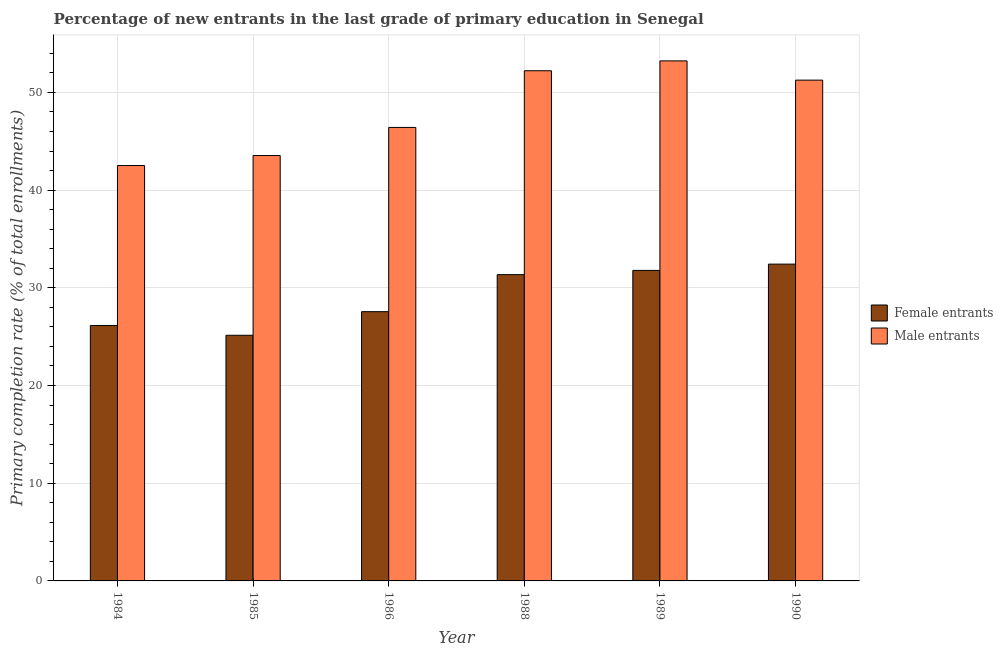How many groups of bars are there?
Offer a very short reply. 6. How many bars are there on the 1st tick from the right?
Your answer should be compact. 2. What is the label of the 1st group of bars from the left?
Provide a succinct answer. 1984. In how many cases, is the number of bars for a given year not equal to the number of legend labels?
Your answer should be very brief. 0. What is the primary completion rate of female entrants in 1985?
Your answer should be very brief. 25.14. Across all years, what is the maximum primary completion rate of male entrants?
Offer a very short reply. 53.23. Across all years, what is the minimum primary completion rate of male entrants?
Your answer should be very brief. 42.52. What is the total primary completion rate of male entrants in the graph?
Your answer should be very brief. 289.19. What is the difference between the primary completion rate of male entrants in 1985 and that in 1986?
Ensure brevity in your answer.  -2.88. What is the difference between the primary completion rate of male entrants in 1990 and the primary completion rate of female entrants in 1984?
Ensure brevity in your answer.  8.74. What is the average primary completion rate of female entrants per year?
Provide a short and direct response. 29.07. What is the ratio of the primary completion rate of female entrants in 1984 to that in 1988?
Your answer should be very brief. 0.83. What is the difference between the highest and the second highest primary completion rate of female entrants?
Provide a short and direct response. 0.64. What is the difference between the highest and the lowest primary completion rate of female entrants?
Your answer should be compact. 7.28. What does the 1st bar from the left in 1984 represents?
Keep it short and to the point. Female entrants. What does the 1st bar from the right in 1985 represents?
Keep it short and to the point. Male entrants. What is the difference between two consecutive major ticks on the Y-axis?
Provide a succinct answer. 10. Does the graph contain any zero values?
Your response must be concise. No. Does the graph contain grids?
Make the answer very short. Yes. How many legend labels are there?
Your response must be concise. 2. What is the title of the graph?
Make the answer very short. Percentage of new entrants in the last grade of primary education in Senegal. Does "RDB concessional" appear as one of the legend labels in the graph?
Offer a terse response. No. What is the label or title of the X-axis?
Your answer should be very brief. Year. What is the label or title of the Y-axis?
Your answer should be very brief. Primary completion rate (% of total enrollments). What is the Primary completion rate (% of total enrollments) of Female entrants in 1984?
Offer a very short reply. 26.14. What is the Primary completion rate (% of total enrollments) of Male entrants in 1984?
Ensure brevity in your answer.  42.52. What is the Primary completion rate (% of total enrollments) in Female entrants in 1985?
Provide a succinct answer. 25.14. What is the Primary completion rate (% of total enrollments) of Male entrants in 1985?
Offer a very short reply. 43.54. What is the Primary completion rate (% of total enrollments) in Female entrants in 1986?
Provide a short and direct response. 27.56. What is the Primary completion rate (% of total enrollments) of Male entrants in 1986?
Offer a very short reply. 46.42. What is the Primary completion rate (% of total enrollments) in Female entrants in 1988?
Provide a succinct answer. 31.35. What is the Primary completion rate (% of total enrollments) of Male entrants in 1988?
Your answer should be very brief. 52.22. What is the Primary completion rate (% of total enrollments) of Female entrants in 1989?
Your answer should be very brief. 31.78. What is the Primary completion rate (% of total enrollments) in Male entrants in 1989?
Offer a very short reply. 53.23. What is the Primary completion rate (% of total enrollments) in Female entrants in 1990?
Ensure brevity in your answer.  32.43. What is the Primary completion rate (% of total enrollments) of Male entrants in 1990?
Your answer should be compact. 51.26. Across all years, what is the maximum Primary completion rate (% of total enrollments) of Female entrants?
Ensure brevity in your answer.  32.43. Across all years, what is the maximum Primary completion rate (% of total enrollments) in Male entrants?
Give a very brief answer. 53.23. Across all years, what is the minimum Primary completion rate (% of total enrollments) of Female entrants?
Provide a succinct answer. 25.14. Across all years, what is the minimum Primary completion rate (% of total enrollments) of Male entrants?
Ensure brevity in your answer.  42.52. What is the total Primary completion rate (% of total enrollments) of Female entrants in the graph?
Your answer should be very brief. 174.41. What is the total Primary completion rate (% of total enrollments) in Male entrants in the graph?
Ensure brevity in your answer.  289.19. What is the difference between the Primary completion rate (% of total enrollments) of Male entrants in 1984 and that in 1985?
Offer a very short reply. -1.02. What is the difference between the Primary completion rate (% of total enrollments) in Female entrants in 1984 and that in 1986?
Provide a short and direct response. -1.42. What is the difference between the Primary completion rate (% of total enrollments) of Male entrants in 1984 and that in 1986?
Make the answer very short. -3.9. What is the difference between the Primary completion rate (% of total enrollments) in Female entrants in 1984 and that in 1988?
Make the answer very short. -5.21. What is the difference between the Primary completion rate (% of total enrollments) in Male entrants in 1984 and that in 1988?
Offer a terse response. -9.7. What is the difference between the Primary completion rate (% of total enrollments) of Female entrants in 1984 and that in 1989?
Make the answer very short. -5.64. What is the difference between the Primary completion rate (% of total enrollments) in Male entrants in 1984 and that in 1989?
Provide a short and direct response. -10.71. What is the difference between the Primary completion rate (% of total enrollments) of Female entrants in 1984 and that in 1990?
Ensure brevity in your answer.  -6.28. What is the difference between the Primary completion rate (% of total enrollments) in Male entrants in 1984 and that in 1990?
Offer a terse response. -8.74. What is the difference between the Primary completion rate (% of total enrollments) in Female entrants in 1985 and that in 1986?
Give a very brief answer. -2.42. What is the difference between the Primary completion rate (% of total enrollments) of Male entrants in 1985 and that in 1986?
Your response must be concise. -2.88. What is the difference between the Primary completion rate (% of total enrollments) in Female entrants in 1985 and that in 1988?
Keep it short and to the point. -6.21. What is the difference between the Primary completion rate (% of total enrollments) of Male entrants in 1985 and that in 1988?
Provide a short and direct response. -8.68. What is the difference between the Primary completion rate (% of total enrollments) of Female entrants in 1985 and that in 1989?
Keep it short and to the point. -6.64. What is the difference between the Primary completion rate (% of total enrollments) in Male entrants in 1985 and that in 1989?
Offer a terse response. -9.69. What is the difference between the Primary completion rate (% of total enrollments) in Female entrants in 1985 and that in 1990?
Your response must be concise. -7.28. What is the difference between the Primary completion rate (% of total enrollments) of Male entrants in 1985 and that in 1990?
Your answer should be compact. -7.72. What is the difference between the Primary completion rate (% of total enrollments) of Female entrants in 1986 and that in 1988?
Ensure brevity in your answer.  -3.79. What is the difference between the Primary completion rate (% of total enrollments) in Male entrants in 1986 and that in 1988?
Your response must be concise. -5.8. What is the difference between the Primary completion rate (% of total enrollments) in Female entrants in 1986 and that in 1989?
Provide a short and direct response. -4.22. What is the difference between the Primary completion rate (% of total enrollments) in Male entrants in 1986 and that in 1989?
Make the answer very short. -6.81. What is the difference between the Primary completion rate (% of total enrollments) of Female entrants in 1986 and that in 1990?
Ensure brevity in your answer.  -4.87. What is the difference between the Primary completion rate (% of total enrollments) in Male entrants in 1986 and that in 1990?
Your answer should be very brief. -4.84. What is the difference between the Primary completion rate (% of total enrollments) in Female entrants in 1988 and that in 1989?
Your answer should be very brief. -0.43. What is the difference between the Primary completion rate (% of total enrollments) in Male entrants in 1988 and that in 1989?
Your answer should be compact. -1.01. What is the difference between the Primary completion rate (% of total enrollments) in Female entrants in 1988 and that in 1990?
Offer a very short reply. -1.08. What is the difference between the Primary completion rate (% of total enrollments) of Male entrants in 1988 and that in 1990?
Give a very brief answer. 0.96. What is the difference between the Primary completion rate (% of total enrollments) of Female entrants in 1989 and that in 1990?
Provide a succinct answer. -0.64. What is the difference between the Primary completion rate (% of total enrollments) in Male entrants in 1989 and that in 1990?
Your answer should be compact. 1.97. What is the difference between the Primary completion rate (% of total enrollments) in Female entrants in 1984 and the Primary completion rate (% of total enrollments) in Male entrants in 1985?
Your response must be concise. -17.4. What is the difference between the Primary completion rate (% of total enrollments) in Female entrants in 1984 and the Primary completion rate (% of total enrollments) in Male entrants in 1986?
Your response must be concise. -20.27. What is the difference between the Primary completion rate (% of total enrollments) in Female entrants in 1984 and the Primary completion rate (% of total enrollments) in Male entrants in 1988?
Provide a succinct answer. -26.07. What is the difference between the Primary completion rate (% of total enrollments) of Female entrants in 1984 and the Primary completion rate (% of total enrollments) of Male entrants in 1989?
Keep it short and to the point. -27.09. What is the difference between the Primary completion rate (% of total enrollments) in Female entrants in 1984 and the Primary completion rate (% of total enrollments) in Male entrants in 1990?
Make the answer very short. -25.11. What is the difference between the Primary completion rate (% of total enrollments) of Female entrants in 1985 and the Primary completion rate (% of total enrollments) of Male entrants in 1986?
Keep it short and to the point. -21.27. What is the difference between the Primary completion rate (% of total enrollments) in Female entrants in 1985 and the Primary completion rate (% of total enrollments) in Male entrants in 1988?
Offer a very short reply. -27.08. What is the difference between the Primary completion rate (% of total enrollments) of Female entrants in 1985 and the Primary completion rate (% of total enrollments) of Male entrants in 1989?
Offer a very short reply. -28.09. What is the difference between the Primary completion rate (% of total enrollments) in Female entrants in 1985 and the Primary completion rate (% of total enrollments) in Male entrants in 1990?
Keep it short and to the point. -26.12. What is the difference between the Primary completion rate (% of total enrollments) of Female entrants in 1986 and the Primary completion rate (% of total enrollments) of Male entrants in 1988?
Your answer should be very brief. -24.66. What is the difference between the Primary completion rate (% of total enrollments) of Female entrants in 1986 and the Primary completion rate (% of total enrollments) of Male entrants in 1989?
Your answer should be very brief. -25.67. What is the difference between the Primary completion rate (% of total enrollments) of Female entrants in 1986 and the Primary completion rate (% of total enrollments) of Male entrants in 1990?
Make the answer very short. -23.7. What is the difference between the Primary completion rate (% of total enrollments) of Female entrants in 1988 and the Primary completion rate (% of total enrollments) of Male entrants in 1989?
Provide a short and direct response. -21.88. What is the difference between the Primary completion rate (% of total enrollments) in Female entrants in 1988 and the Primary completion rate (% of total enrollments) in Male entrants in 1990?
Your answer should be compact. -19.91. What is the difference between the Primary completion rate (% of total enrollments) of Female entrants in 1989 and the Primary completion rate (% of total enrollments) of Male entrants in 1990?
Keep it short and to the point. -19.48. What is the average Primary completion rate (% of total enrollments) in Female entrants per year?
Your response must be concise. 29.07. What is the average Primary completion rate (% of total enrollments) in Male entrants per year?
Offer a terse response. 48.2. In the year 1984, what is the difference between the Primary completion rate (% of total enrollments) in Female entrants and Primary completion rate (% of total enrollments) in Male entrants?
Your response must be concise. -16.37. In the year 1985, what is the difference between the Primary completion rate (% of total enrollments) of Female entrants and Primary completion rate (% of total enrollments) of Male entrants?
Provide a short and direct response. -18.4. In the year 1986, what is the difference between the Primary completion rate (% of total enrollments) in Female entrants and Primary completion rate (% of total enrollments) in Male entrants?
Your response must be concise. -18.86. In the year 1988, what is the difference between the Primary completion rate (% of total enrollments) in Female entrants and Primary completion rate (% of total enrollments) in Male entrants?
Offer a terse response. -20.87. In the year 1989, what is the difference between the Primary completion rate (% of total enrollments) of Female entrants and Primary completion rate (% of total enrollments) of Male entrants?
Your answer should be compact. -21.45. In the year 1990, what is the difference between the Primary completion rate (% of total enrollments) in Female entrants and Primary completion rate (% of total enrollments) in Male entrants?
Your answer should be compact. -18.83. What is the ratio of the Primary completion rate (% of total enrollments) of Female entrants in 1984 to that in 1985?
Offer a terse response. 1.04. What is the ratio of the Primary completion rate (% of total enrollments) in Male entrants in 1984 to that in 1985?
Your answer should be very brief. 0.98. What is the ratio of the Primary completion rate (% of total enrollments) in Female entrants in 1984 to that in 1986?
Give a very brief answer. 0.95. What is the ratio of the Primary completion rate (% of total enrollments) in Male entrants in 1984 to that in 1986?
Ensure brevity in your answer.  0.92. What is the ratio of the Primary completion rate (% of total enrollments) of Female entrants in 1984 to that in 1988?
Make the answer very short. 0.83. What is the ratio of the Primary completion rate (% of total enrollments) in Male entrants in 1984 to that in 1988?
Make the answer very short. 0.81. What is the ratio of the Primary completion rate (% of total enrollments) in Female entrants in 1984 to that in 1989?
Offer a very short reply. 0.82. What is the ratio of the Primary completion rate (% of total enrollments) of Male entrants in 1984 to that in 1989?
Offer a terse response. 0.8. What is the ratio of the Primary completion rate (% of total enrollments) of Female entrants in 1984 to that in 1990?
Provide a short and direct response. 0.81. What is the ratio of the Primary completion rate (% of total enrollments) in Male entrants in 1984 to that in 1990?
Your response must be concise. 0.83. What is the ratio of the Primary completion rate (% of total enrollments) in Female entrants in 1985 to that in 1986?
Ensure brevity in your answer.  0.91. What is the ratio of the Primary completion rate (% of total enrollments) of Male entrants in 1985 to that in 1986?
Provide a short and direct response. 0.94. What is the ratio of the Primary completion rate (% of total enrollments) of Female entrants in 1985 to that in 1988?
Offer a terse response. 0.8. What is the ratio of the Primary completion rate (% of total enrollments) of Male entrants in 1985 to that in 1988?
Give a very brief answer. 0.83. What is the ratio of the Primary completion rate (% of total enrollments) of Female entrants in 1985 to that in 1989?
Offer a very short reply. 0.79. What is the ratio of the Primary completion rate (% of total enrollments) in Male entrants in 1985 to that in 1989?
Ensure brevity in your answer.  0.82. What is the ratio of the Primary completion rate (% of total enrollments) of Female entrants in 1985 to that in 1990?
Provide a short and direct response. 0.78. What is the ratio of the Primary completion rate (% of total enrollments) in Male entrants in 1985 to that in 1990?
Your answer should be very brief. 0.85. What is the ratio of the Primary completion rate (% of total enrollments) of Female entrants in 1986 to that in 1988?
Keep it short and to the point. 0.88. What is the ratio of the Primary completion rate (% of total enrollments) of Female entrants in 1986 to that in 1989?
Offer a terse response. 0.87. What is the ratio of the Primary completion rate (% of total enrollments) in Male entrants in 1986 to that in 1989?
Your response must be concise. 0.87. What is the ratio of the Primary completion rate (% of total enrollments) in Female entrants in 1986 to that in 1990?
Keep it short and to the point. 0.85. What is the ratio of the Primary completion rate (% of total enrollments) in Male entrants in 1986 to that in 1990?
Ensure brevity in your answer.  0.91. What is the ratio of the Primary completion rate (% of total enrollments) in Female entrants in 1988 to that in 1989?
Your answer should be compact. 0.99. What is the ratio of the Primary completion rate (% of total enrollments) in Female entrants in 1988 to that in 1990?
Offer a very short reply. 0.97. What is the ratio of the Primary completion rate (% of total enrollments) in Male entrants in 1988 to that in 1990?
Your answer should be compact. 1.02. What is the ratio of the Primary completion rate (% of total enrollments) in Female entrants in 1989 to that in 1990?
Your response must be concise. 0.98. What is the ratio of the Primary completion rate (% of total enrollments) in Male entrants in 1989 to that in 1990?
Ensure brevity in your answer.  1.04. What is the difference between the highest and the second highest Primary completion rate (% of total enrollments) in Female entrants?
Make the answer very short. 0.64. What is the difference between the highest and the second highest Primary completion rate (% of total enrollments) of Male entrants?
Make the answer very short. 1.01. What is the difference between the highest and the lowest Primary completion rate (% of total enrollments) in Female entrants?
Provide a short and direct response. 7.28. What is the difference between the highest and the lowest Primary completion rate (% of total enrollments) of Male entrants?
Make the answer very short. 10.71. 